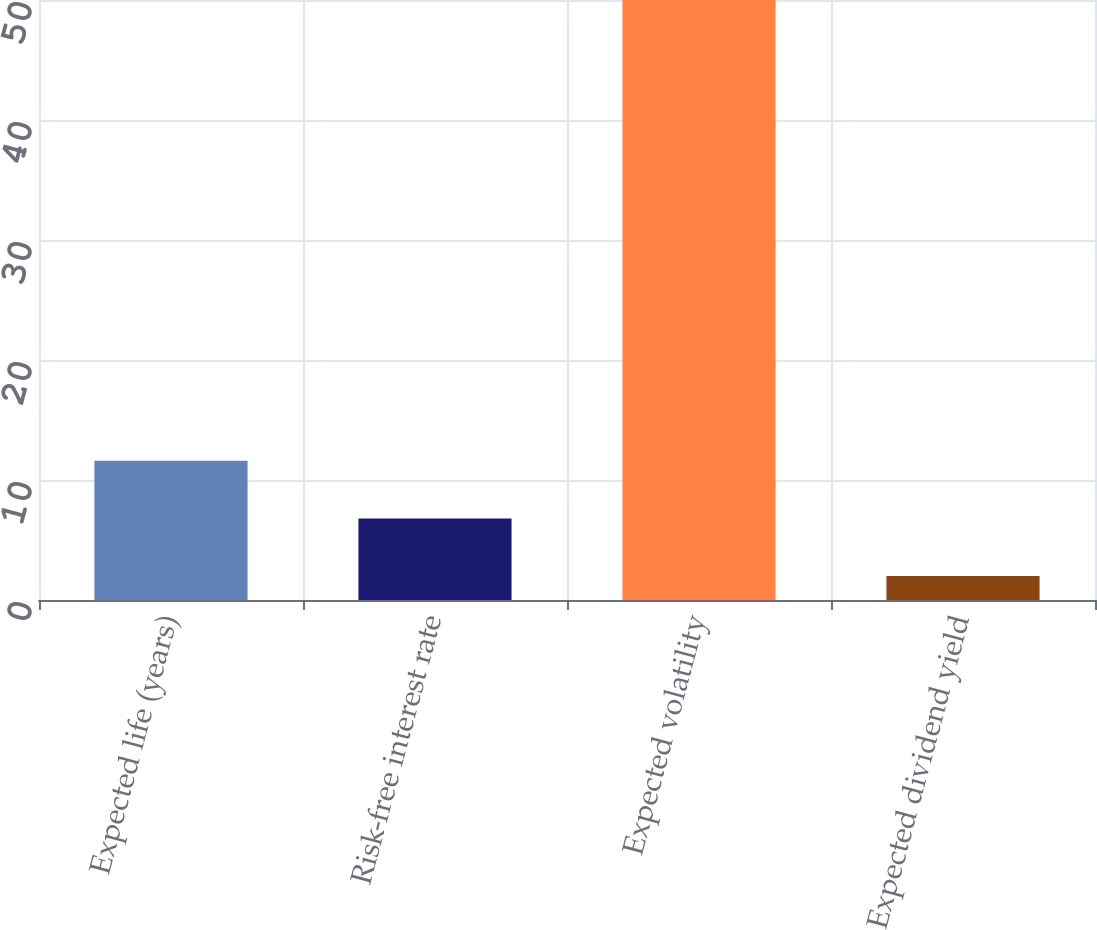Convert chart. <chart><loc_0><loc_0><loc_500><loc_500><bar_chart><fcel>Expected life (years)<fcel>Risk-free interest rate<fcel>Expected volatility<fcel>Expected dividend yield<nl><fcel>11.6<fcel>6.8<fcel>50<fcel>2<nl></chart> 